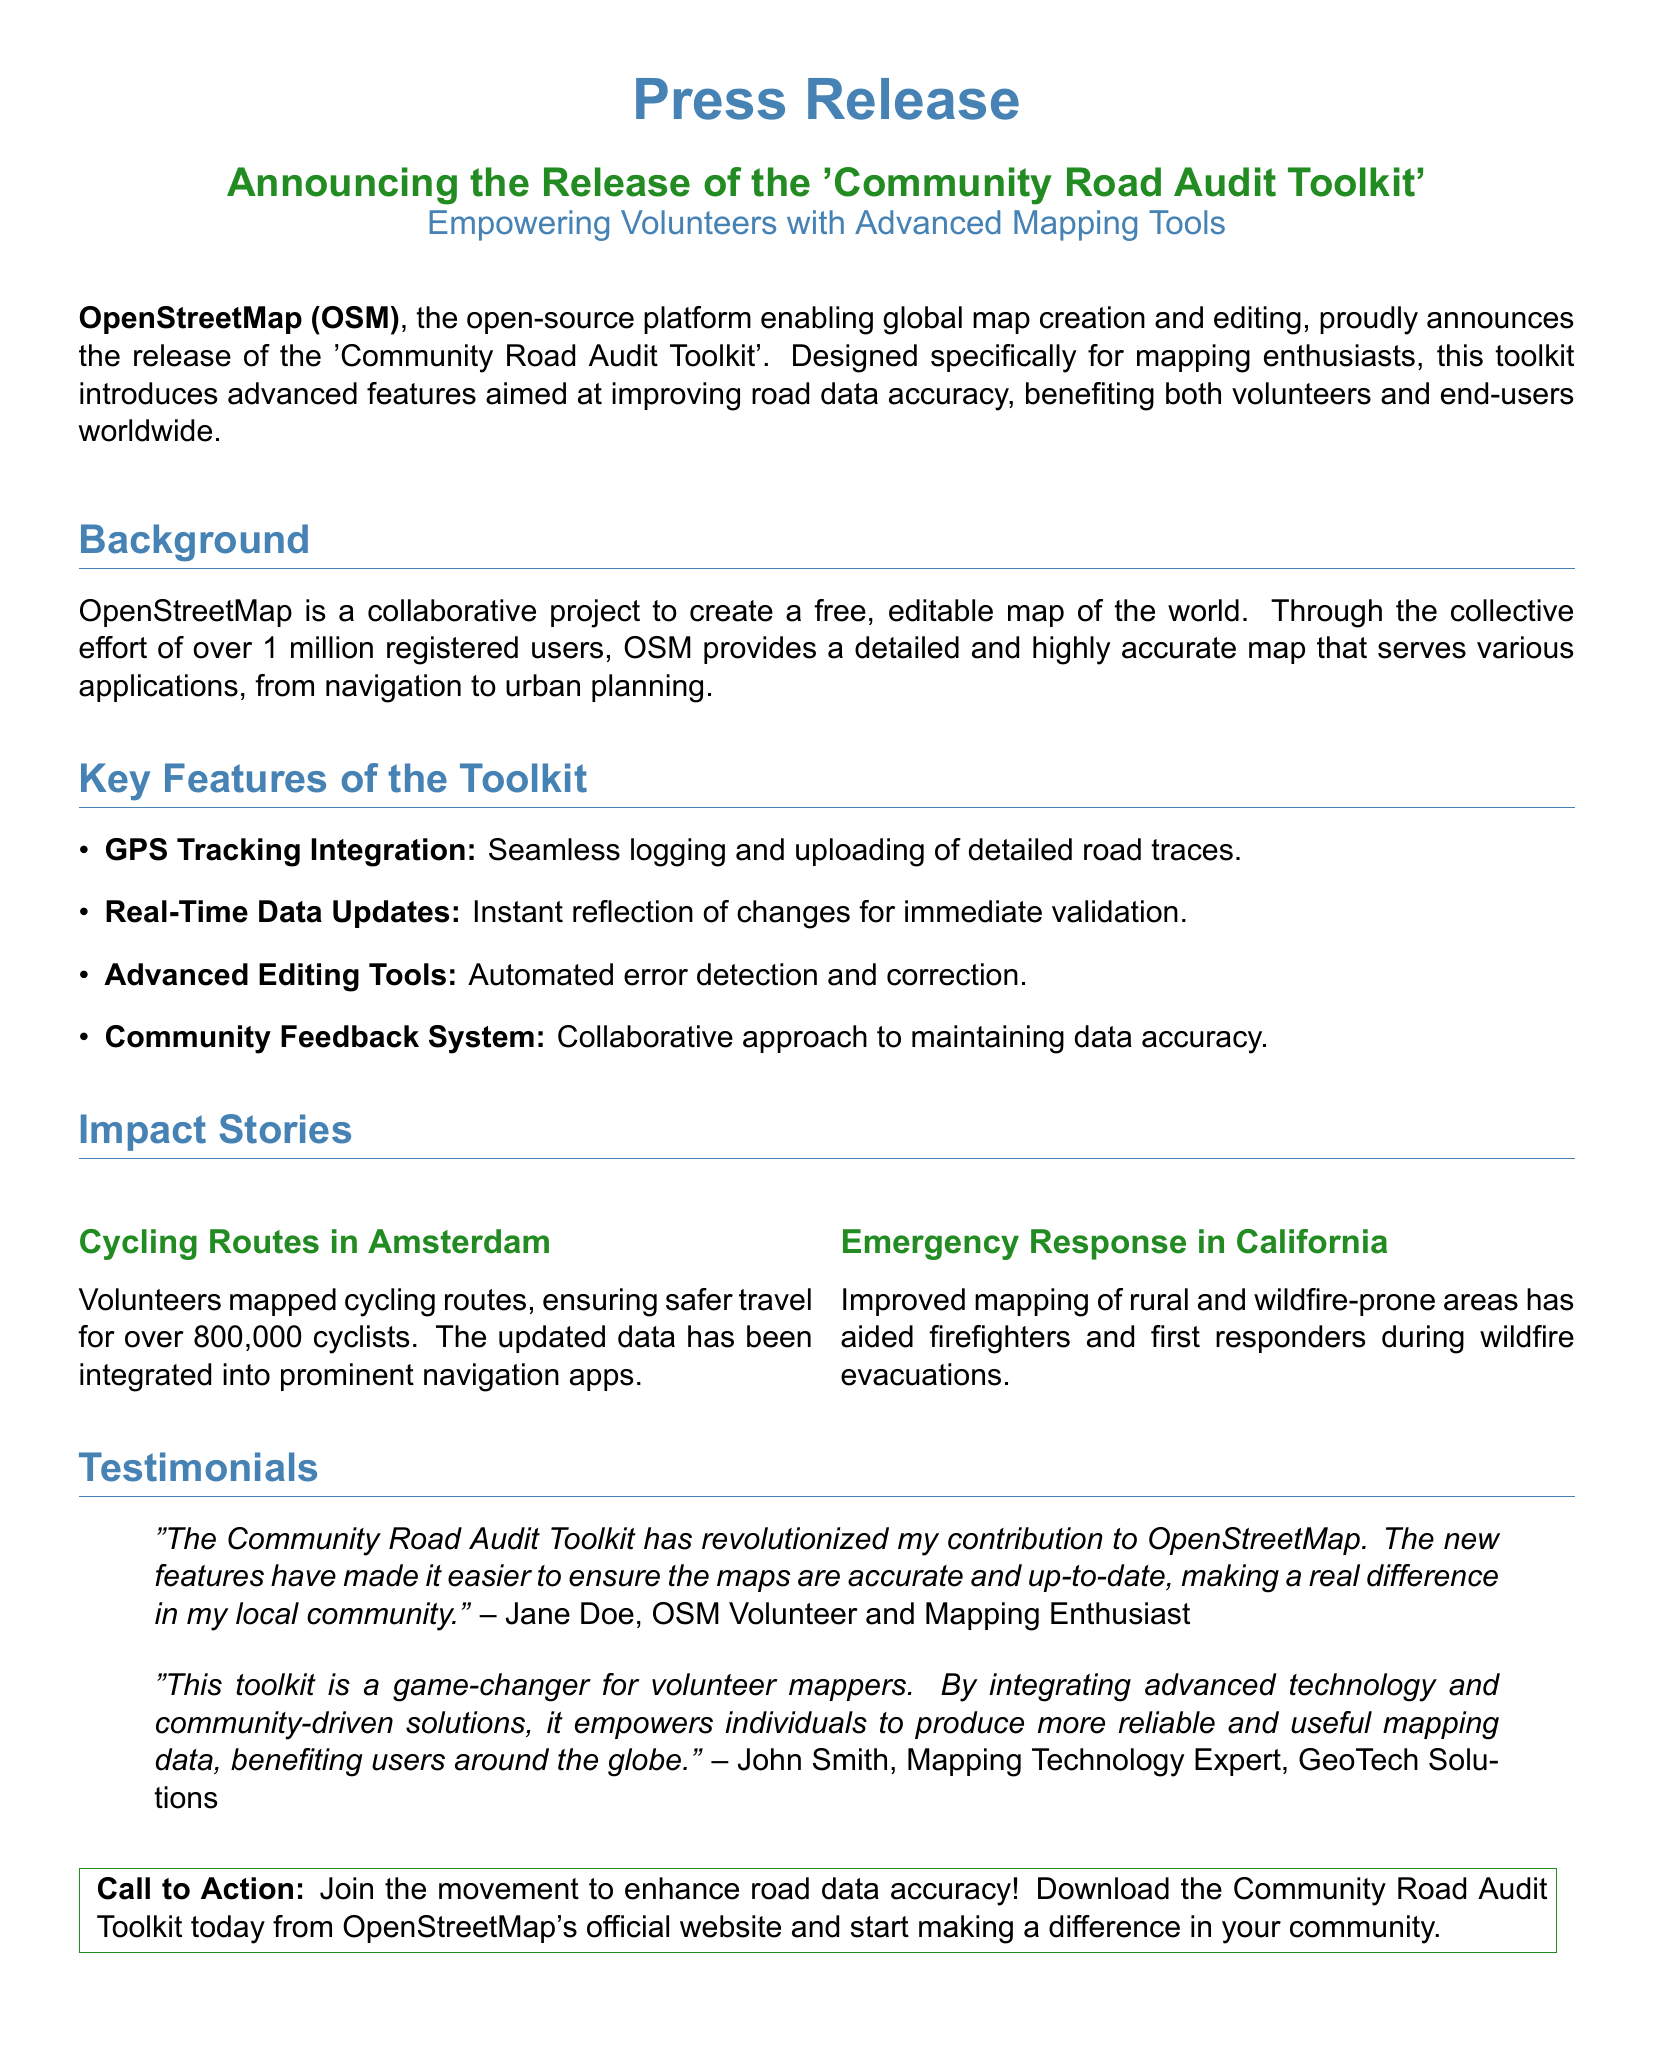What is the toolkit's name? The toolkit is specifically named in the document, highlighting its purpose for the community.
Answer: Community Road Audit Toolkit How many registered users does OpenStreetMap have? The document mentions the total number of registered users contributing to OpenStreetMap, indicating its scale.
Answer: over 1 million What feature allows seamless logging of road traces? The document specifies a key feature that enables mapping volunteers to track roads efficiently.
Answer: GPS Tracking Integration Which city’s cycling routes were improved? The document provides an example of a location where community mapping efforts were successfully implemented.
Answer: Amsterdam Who provided a testimonial indicating a significant impact from the toolkit? The document cites a volunteer’s name who expressed the toolkit's influence on their contributions.
Answer: Jane Doe What is one of the impact stories about emergency response? The document presents an example related to disaster management and mapping improvements in a specific region.
Answer: California What is the call to action in the document? The document concludes with an invitation encouraging participation in the mapping effort by downloading the toolkit.
Answer: Join the movement to enhance road data accuracy What does the toolkit promote for data accuracy? An essential aspect mentioned in the document reflects the collaborative nature of the toolkit’s approach to ensuring quality mapping.
Answer: Community Feedback System 